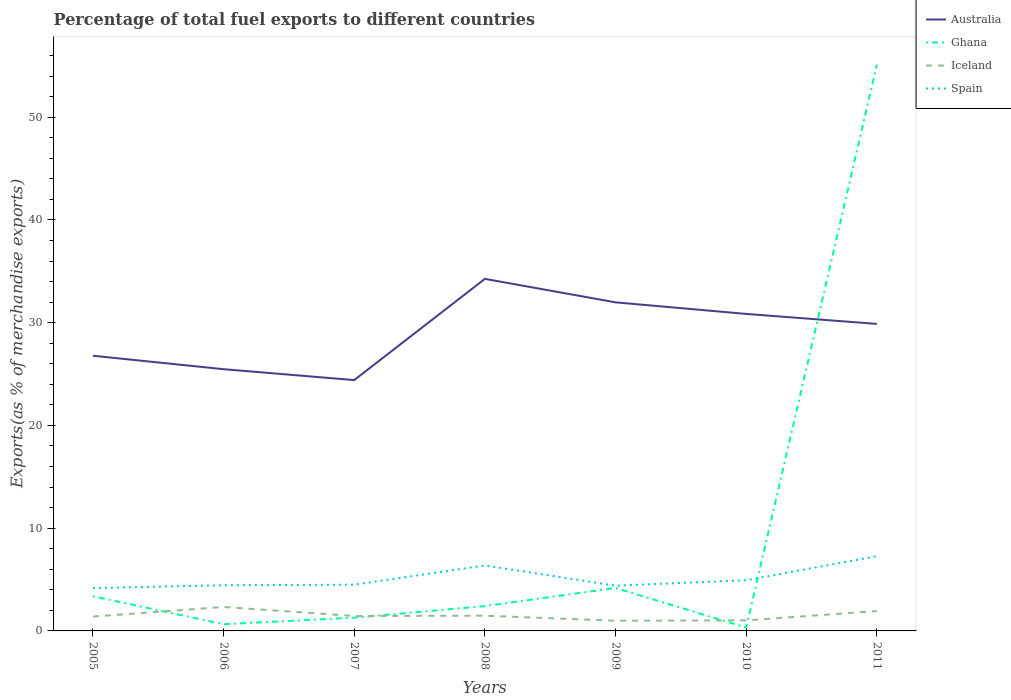Is the number of lines equal to the number of legend labels?
Ensure brevity in your answer.  Yes. Across all years, what is the maximum percentage of exports to different countries in Australia?
Ensure brevity in your answer.  24.42. What is the total percentage of exports to different countries in Spain in the graph?
Ensure brevity in your answer.  -0.27. What is the difference between the highest and the second highest percentage of exports to different countries in Ghana?
Your answer should be compact. 54.79. Is the percentage of exports to different countries in Ghana strictly greater than the percentage of exports to different countries in Spain over the years?
Offer a terse response. No. How many lines are there?
Provide a succinct answer. 4. Does the graph contain grids?
Make the answer very short. No. Where does the legend appear in the graph?
Offer a very short reply. Top right. How many legend labels are there?
Provide a succinct answer. 4. How are the legend labels stacked?
Ensure brevity in your answer.  Vertical. What is the title of the graph?
Keep it short and to the point. Percentage of total fuel exports to different countries. Does "Belgium" appear as one of the legend labels in the graph?
Give a very brief answer. No. What is the label or title of the X-axis?
Keep it short and to the point. Years. What is the label or title of the Y-axis?
Ensure brevity in your answer.  Exports(as % of merchandise exports). What is the Exports(as % of merchandise exports) of Australia in 2005?
Make the answer very short. 26.79. What is the Exports(as % of merchandise exports) of Ghana in 2005?
Provide a succinct answer. 3.38. What is the Exports(as % of merchandise exports) of Iceland in 2005?
Your answer should be very brief. 1.4. What is the Exports(as % of merchandise exports) of Spain in 2005?
Provide a succinct answer. 4.17. What is the Exports(as % of merchandise exports) in Australia in 2006?
Your answer should be compact. 25.48. What is the Exports(as % of merchandise exports) in Ghana in 2006?
Offer a terse response. 0.65. What is the Exports(as % of merchandise exports) of Iceland in 2006?
Make the answer very short. 2.33. What is the Exports(as % of merchandise exports) in Spain in 2006?
Your answer should be compact. 4.45. What is the Exports(as % of merchandise exports) in Australia in 2007?
Provide a short and direct response. 24.42. What is the Exports(as % of merchandise exports) of Ghana in 2007?
Ensure brevity in your answer.  1.29. What is the Exports(as % of merchandise exports) of Iceland in 2007?
Make the answer very short. 1.45. What is the Exports(as % of merchandise exports) in Spain in 2007?
Ensure brevity in your answer.  4.5. What is the Exports(as % of merchandise exports) of Australia in 2008?
Provide a succinct answer. 34.27. What is the Exports(as % of merchandise exports) of Ghana in 2008?
Keep it short and to the point. 2.42. What is the Exports(as % of merchandise exports) in Iceland in 2008?
Provide a succinct answer. 1.48. What is the Exports(as % of merchandise exports) in Spain in 2008?
Provide a succinct answer. 6.37. What is the Exports(as % of merchandise exports) of Australia in 2009?
Offer a terse response. 31.98. What is the Exports(as % of merchandise exports) in Ghana in 2009?
Your answer should be very brief. 4.18. What is the Exports(as % of merchandise exports) of Iceland in 2009?
Provide a short and direct response. 0.99. What is the Exports(as % of merchandise exports) of Spain in 2009?
Your answer should be compact. 4.41. What is the Exports(as % of merchandise exports) of Australia in 2010?
Provide a succinct answer. 30.86. What is the Exports(as % of merchandise exports) in Ghana in 2010?
Provide a short and direct response. 0.32. What is the Exports(as % of merchandise exports) of Iceland in 2010?
Give a very brief answer. 1.03. What is the Exports(as % of merchandise exports) of Spain in 2010?
Provide a succinct answer. 4.93. What is the Exports(as % of merchandise exports) of Australia in 2011?
Your answer should be compact. 29.88. What is the Exports(as % of merchandise exports) in Ghana in 2011?
Offer a very short reply. 55.11. What is the Exports(as % of merchandise exports) in Iceland in 2011?
Your answer should be very brief. 1.93. What is the Exports(as % of merchandise exports) in Spain in 2011?
Your response must be concise. 7.27. Across all years, what is the maximum Exports(as % of merchandise exports) in Australia?
Provide a short and direct response. 34.27. Across all years, what is the maximum Exports(as % of merchandise exports) of Ghana?
Provide a succinct answer. 55.11. Across all years, what is the maximum Exports(as % of merchandise exports) of Iceland?
Offer a terse response. 2.33. Across all years, what is the maximum Exports(as % of merchandise exports) in Spain?
Offer a terse response. 7.27. Across all years, what is the minimum Exports(as % of merchandise exports) of Australia?
Keep it short and to the point. 24.42. Across all years, what is the minimum Exports(as % of merchandise exports) in Ghana?
Give a very brief answer. 0.32. Across all years, what is the minimum Exports(as % of merchandise exports) of Iceland?
Provide a succinct answer. 0.99. Across all years, what is the minimum Exports(as % of merchandise exports) of Spain?
Keep it short and to the point. 4.17. What is the total Exports(as % of merchandise exports) in Australia in the graph?
Provide a succinct answer. 203.67. What is the total Exports(as % of merchandise exports) in Ghana in the graph?
Your response must be concise. 67.36. What is the total Exports(as % of merchandise exports) in Iceland in the graph?
Your answer should be compact. 10.62. What is the total Exports(as % of merchandise exports) in Spain in the graph?
Make the answer very short. 36.11. What is the difference between the Exports(as % of merchandise exports) of Australia in 2005 and that in 2006?
Provide a short and direct response. 1.31. What is the difference between the Exports(as % of merchandise exports) in Ghana in 2005 and that in 2006?
Your answer should be compact. 2.72. What is the difference between the Exports(as % of merchandise exports) of Iceland in 2005 and that in 2006?
Provide a short and direct response. -0.93. What is the difference between the Exports(as % of merchandise exports) in Spain in 2005 and that in 2006?
Ensure brevity in your answer.  -0.27. What is the difference between the Exports(as % of merchandise exports) of Australia in 2005 and that in 2007?
Your response must be concise. 2.37. What is the difference between the Exports(as % of merchandise exports) in Ghana in 2005 and that in 2007?
Your response must be concise. 2.08. What is the difference between the Exports(as % of merchandise exports) in Iceland in 2005 and that in 2007?
Offer a terse response. -0.06. What is the difference between the Exports(as % of merchandise exports) in Spain in 2005 and that in 2007?
Offer a terse response. -0.33. What is the difference between the Exports(as % of merchandise exports) in Australia in 2005 and that in 2008?
Your answer should be compact. -7.48. What is the difference between the Exports(as % of merchandise exports) in Ghana in 2005 and that in 2008?
Provide a short and direct response. 0.96. What is the difference between the Exports(as % of merchandise exports) in Iceland in 2005 and that in 2008?
Offer a very short reply. -0.09. What is the difference between the Exports(as % of merchandise exports) in Spain in 2005 and that in 2008?
Your answer should be very brief. -2.2. What is the difference between the Exports(as % of merchandise exports) of Australia in 2005 and that in 2009?
Provide a succinct answer. -5.2. What is the difference between the Exports(as % of merchandise exports) of Ghana in 2005 and that in 2009?
Give a very brief answer. -0.81. What is the difference between the Exports(as % of merchandise exports) of Iceland in 2005 and that in 2009?
Offer a very short reply. 0.41. What is the difference between the Exports(as % of merchandise exports) in Spain in 2005 and that in 2009?
Keep it short and to the point. -0.23. What is the difference between the Exports(as % of merchandise exports) in Australia in 2005 and that in 2010?
Offer a very short reply. -4.07. What is the difference between the Exports(as % of merchandise exports) in Ghana in 2005 and that in 2010?
Keep it short and to the point. 3.05. What is the difference between the Exports(as % of merchandise exports) in Iceland in 2005 and that in 2010?
Provide a short and direct response. 0.37. What is the difference between the Exports(as % of merchandise exports) of Spain in 2005 and that in 2010?
Provide a short and direct response. -0.76. What is the difference between the Exports(as % of merchandise exports) in Australia in 2005 and that in 2011?
Your answer should be compact. -3.1. What is the difference between the Exports(as % of merchandise exports) of Ghana in 2005 and that in 2011?
Your response must be concise. -51.74. What is the difference between the Exports(as % of merchandise exports) in Iceland in 2005 and that in 2011?
Your response must be concise. -0.54. What is the difference between the Exports(as % of merchandise exports) of Spain in 2005 and that in 2011?
Give a very brief answer. -3.1. What is the difference between the Exports(as % of merchandise exports) in Australia in 2006 and that in 2007?
Your answer should be compact. 1.06. What is the difference between the Exports(as % of merchandise exports) in Ghana in 2006 and that in 2007?
Your answer should be very brief. -0.64. What is the difference between the Exports(as % of merchandise exports) of Iceland in 2006 and that in 2007?
Your answer should be very brief. 0.88. What is the difference between the Exports(as % of merchandise exports) in Spain in 2006 and that in 2007?
Provide a succinct answer. -0.05. What is the difference between the Exports(as % of merchandise exports) of Australia in 2006 and that in 2008?
Your answer should be very brief. -8.79. What is the difference between the Exports(as % of merchandise exports) of Ghana in 2006 and that in 2008?
Your response must be concise. -1.76. What is the difference between the Exports(as % of merchandise exports) of Iceland in 2006 and that in 2008?
Ensure brevity in your answer.  0.85. What is the difference between the Exports(as % of merchandise exports) in Spain in 2006 and that in 2008?
Offer a terse response. -1.93. What is the difference between the Exports(as % of merchandise exports) in Australia in 2006 and that in 2009?
Offer a terse response. -6.51. What is the difference between the Exports(as % of merchandise exports) in Ghana in 2006 and that in 2009?
Offer a terse response. -3.53. What is the difference between the Exports(as % of merchandise exports) in Iceland in 2006 and that in 2009?
Offer a very short reply. 1.34. What is the difference between the Exports(as % of merchandise exports) in Spain in 2006 and that in 2009?
Ensure brevity in your answer.  0.04. What is the difference between the Exports(as % of merchandise exports) of Australia in 2006 and that in 2010?
Offer a very short reply. -5.38. What is the difference between the Exports(as % of merchandise exports) in Ghana in 2006 and that in 2010?
Provide a succinct answer. 0.33. What is the difference between the Exports(as % of merchandise exports) of Iceland in 2006 and that in 2010?
Give a very brief answer. 1.3. What is the difference between the Exports(as % of merchandise exports) of Spain in 2006 and that in 2010?
Your answer should be compact. -0.49. What is the difference between the Exports(as % of merchandise exports) in Australia in 2006 and that in 2011?
Provide a succinct answer. -4.41. What is the difference between the Exports(as % of merchandise exports) in Ghana in 2006 and that in 2011?
Provide a succinct answer. -54.46. What is the difference between the Exports(as % of merchandise exports) of Iceland in 2006 and that in 2011?
Offer a very short reply. 0.4. What is the difference between the Exports(as % of merchandise exports) of Spain in 2006 and that in 2011?
Make the answer very short. -2.82. What is the difference between the Exports(as % of merchandise exports) of Australia in 2007 and that in 2008?
Provide a short and direct response. -9.85. What is the difference between the Exports(as % of merchandise exports) of Ghana in 2007 and that in 2008?
Keep it short and to the point. -1.12. What is the difference between the Exports(as % of merchandise exports) of Iceland in 2007 and that in 2008?
Provide a short and direct response. -0.03. What is the difference between the Exports(as % of merchandise exports) of Spain in 2007 and that in 2008?
Give a very brief answer. -1.87. What is the difference between the Exports(as % of merchandise exports) of Australia in 2007 and that in 2009?
Your response must be concise. -7.57. What is the difference between the Exports(as % of merchandise exports) in Ghana in 2007 and that in 2009?
Give a very brief answer. -2.89. What is the difference between the Exports(as % of merchandise exports) of Iceland in 2007 and that in 2009?
Provide a short and direct response. 0.46. What is the difference between the Exports(as % of merchandise exports) of Spain in 2007 and that in 2009?
Your answer should be very brief. 0.1. What is the difference between the Exports(as % of merchandise exports) in Australia in 2007 and that in 2010?
Your response must be concise. -6.44. What is the difference between the Exports(as % of merchandise exports) in Ghana in 2007 and that in 2010?
Offer a very short reply. 0.97. What is the difference between the Exports(as % of merchandise exports) in Iceland in 2007 and that in 2010?
Provide a succinct answer. 0.43. What is the difference between the Exports(as % of merchandise exports) of Spain in 2007 and that in 2010?
Offer a very short reply. -0.43. What is the difference between the Exports(as % of merchandise exports) of Australia in 2007 and that in 2011?
Provide a short and direct response. -5.47. What is the difference between the Exports(as % of merchandise exports) of Ghana in 2007 and that in 2011?
Offer a terse response. -53.82. What is the difference between the Exports(as % of merchandise exports) in Iceland in 2007 and that in 2011?
Provide a short and direct response. -0.48. What is the difference between the Exports(as % of merchandise exports) in Spain in 2007 and that in 2011?
Provide a short and direct response. -2.77. What is the difference between the Exports(as % of merchandise exports) of Australia in 2008 and that in 2009?
Offer a very short reply. 2.29. What is the difference between the Exports(as % of merchandise exports) of Ghana in 2008 and that in 2009?
Your response must be concise. -1.77. What is the difference between the Exports(as % of merchandise exports) in Iceland in 2008 and that in 2009?
Your answer should be very brief. 0.49. What is the difference between the Exports(as % of merchandise exports) of Spain in 2008 and that in 2009?
Provide a succinct answer. 1.97. What is the difference between the Exports(as % of merchandise exports) of Australia in 2008 and that in 2010?
Keep it short and to the point. 3.41. What is the difference between the Exports(as % of merchandise exports) of Ghana in 2008 and that in 2010?
Your answer should be very brief. 2.09. What is the difference between the Exports(as % of merchandise exports) of Iceland in 2008 and that in 2010?
Your answer should be compact. 0.45. What is the difference between the Exports(as % of merchandise exports) of Spain in 2008 and that in 2010?
Make the answer very short. 1.44. What is the difference between the Exports(as % of merchandise exports) in Australia in 2008 and that in 2011?
Make the answer very short. 4.38. What is the difference between the Exports(as % of merchandise exports) in Ghana in 2008 and that in 2011?
Your answer should be very brief. -52.7. What is the difference between the Exports(as % of merchandise exports) in Iceland in 2008 and that in 2011?
Ensure brevity in your answer.  -0.45. What is the difference between the Exports(as % of merchandise exports) of Spain in 2008 and that in 2011?
Offer a terse response. -0.9. What is the difference between the Exports(as % of merchandise exports) of Australia in 2009 and that in 2010?
Offer a very short reply. 1.13. What is the difference between the Exports(as % of merchandise exports) of Ghana in 2009 and that in 2010?
Your answer should be very brief. 3.86. What is the difference between the Exports(as % of merchandise exports) in Iceland in 2009 and that in 2010?
Provide a succinct answer. -0.04. What is the difference between the Exports(as % of merchandise exports) of Spain in 2009 and that in 2010?
Offer a terse response. -0.53. What is the difference between the Exports(as % of merchandise exports) of Australia in 2009 and that in 2011?
Offer a terse response. 2.1. What is the difference between the Exports(as % of merchandise exports) of Ghana in 2009 and that in 2011?
Your answer should be compact. -50.93. What is the difference between the Exports(as % of merchandise exports) in Iceland in 2009 and that in 2011?
Provide a short and direct response. -0.94. What is the difference between the Exports(as % of merchandise exports) in Spain in 2009 and that in 2011?
Keep it short and to the point. -2.87. What is the difference between the Exports(as % of merchandise exports) in Australia in 2010 and that in 2011?
Give a very brief answer. 0.97. What is the difference between the Exports(as % of merchandise exports) in Ghana in 2010 and that in 2011?
Ensure brevity in your answer.  -54.79. What is the difference between the Exports(as % of merchandise exports) in Iceland in 2010 and that in 2011?
Your response must be concise. -0.9. What is the difference between the Exports(as % of merchandise exports) of Spain in 2010 and that in 2011?
Offer a terse response. -2.34. What is the difference between the Exports(as % of merchandise exports) of Australia in 2005 and the Exports(as % of merchandise exports) of Ghana in 2006?
Provide a succinct answer. 26.13. What is the difference between the Exports(as % of merchandise exports) in Australia in 2005 and the Exports(as % of merchandise exports) in Iceland in 2006?
Offer a terse response. 24.45. What is the difference between the Exports(as % of merchandise exports) in Australia in 2005 and the Exports(as % of merchandise exports) in Spain in 2006?
Offer a terse response. 22.34. What is the difference between the Exports(as % of merchandise exports) of Ghana in 2005 and the Exports(as % of merchandise exports) of Iceland in 2006?
Your answer should be very brief. 1.04. What is the difference between the Exports(as % of merchandise exports) of Ghana in 2005 and the Exports(as % of merchandise exports) of Spain in 2006?
Provide a succinct answer. -1.07. What is the difference between the Exports(as % of merchandise exports) of Iceland in 2005 and the Exports(as % of merchandise exports) of Spain in 2006?
Keep it short and to the point. -3.05. What is the difference between the Exports(as % of merchandise exports) in Australia in 2005 and the Exports(as % of merchandise exports) in Ghana in 2007?
Offer a terse response. 25.49. What is the difference between the Exports(as % of merchandise exports) of Australia in 2005 and the Exports(as % of merchandise exports) of Iceland in 2007?
Your answer should be very brief. 25.33. What is the difference between the Exports(as % of merchandise exports) of Australia in 2005 and the Exports(as % of merchandise exports) of Spain in 2007?
Your response must be concise. 22.28. What is the difference between the Exports(as % of merchandise exports) of Ghana in 2005 and the Exports(as % of merchandise exports) of Iceland in 2007?
Your answer should be very brief. 1.92. What is the difference between the Exports(as % of merchandise exports) in Ghana in 2005 and the Exports(as % of merchandise exports) in Spain in 2007?
Offer a very short reply. -1.13. What is the difference between the Exports(as % of merchandise exports) in Iceland in 2005 and the Exports(as % of merchandise exports) in Spain in 2007?
Keep it short and to the point. -3.1. What is the difference between the Exports(as % of merchandise exports) of Australia in 2005 and the Exports(as % of merchandise exports) of Ghana in 2008?
Make the answer very short. 24.37. What is the difference between the Exports(as % of merchandise exports) in Australia in 2005 and the Exports(as % of merchandise exports) in Iceland in 2008?
Offer a very short reply. 25.3. What is the difference between the Exports(as % of merchandise exports) of Australia in 2005 and the Exports(as % of merchandise exports) of Spain in 2008?
Keep it short and to the point. 20.41. What is the difference between the Exports(as % of merchandise exports) of Ghana in 2005 and the Exports(as % of merchandise exports) of Iceland in 2008?
Keep it short and to the point. 1.89. What is the difference between the Exports(as % of merchandise exports) in Ghana in 2005 and the Exports(as % of merchandise exports) in Spain in 2008?
Ensure brevity in your answer.  -3. What is the difference between the Exports(as % of merchandise exports) of Iceland in 2005 and the Exports(as % of merchandise exports) of Spain in 2008?
Offer a terse response. -4.98. What is the difference between the Exports(as % of merchandise exports) in Australia in 2005 and the Exports(as % of merchandise exports) in Ghana in 2009?
Your answer should be compact. 22.6. What is the difference between the Exports(as % of merchandise exports) of Australia in 2005 and the Exports(as % of merchandise exports) of Iceland in 2009?
Keep it short and to the point. 25.79. What is the difference between the Exports(as % of merchandise exports) in Australia in 2005 and the Exports(as % of merchandise exports) in Spain in 2009?
Provide a succinct answer. 22.38. What is the difference between the Exports(as % of merchandise exports) in Ghana in 2005 and the Exports(as % of merchandise exports) in Iceland in 2009?
Ensure brevity in your answer.  2.38. What is the difference between the Exports(as % of merchandise exports) of Ghana in 2005 and the Exports(as % of merchandise exports) of Spain in 2009?
Provide a succinct answer. -1.03. What is the difference between the Exports(as % of merchandise exports) of Iceland in 2005 and the Exports(as % of merchandise exports) of Spain in 2009?
Ensure brevity in your answer.  -3.01. What is the difference between the Exports(as % of merchandise exports) in Australia in 2005 and the Exports(as % of merchandise exports) in Ghana in 2010?
Keep it short and to the point. 26.46. What is the difference between the Exports(as % of merchandise exports) of Australia in 2005 and the Exports(as % of merchandise exports) of Iceland in 2010?
Ensure brevity in your answer.  25.76. What is the difference between the Exports(as % of merchandise exports) of Australia in 2005 and the Exports(as % of merchandise exports) of Spain in 2010?
Your answer should be very brief. 21.85. What is the difference between the Exports(as % of merchandise exports) of Ghana in 2005 and the Exports(as % of merchandise exports) of Iceland in 2010?
Keep it short and to the point. 2.35. What is the difference between the Exports(as % of merchandise exports) in Ghana in 2005 and the Exports(as % of merchandise exports) in Spain in 2010?
Provide a short and direct response. -1.56. What is the difference between the Exports(as % of merchandise exports) of Iceland in 2005 and the Exports(as % of merchandise exports) of Spain in 2010?
Your answer should be compact. -3.54. What is the difference between the Exports(as % of merchandise exports) of Australia in 2005 and the Exports(as % of merchandise exports) of Ghana in 2011?
Ensure brevity in your answer.  -28.33. What is the difference between the Exports(as % of merchandise exports) of Australia in 2005 and the Exports(as % of merchandise exports) of Iceland in 2011?
Your response must be concise. 24.85. What is the difference between the Exports(as % of merchandise exports) of Australia in 2005 and the Exports(as % of merchandise exports) of Spain in 2011?
Provide a succinct answer. 19.51. What is the difference between the Exports(as % of merchandise exports) of Ghana in 2005 and the Exports(as % of merchandise exports) of Iceland in 2011?
Keep it short and to the point. 1.44. What is the difference between the Exports(as % of merchandise exports) of Ghana in 2005 and the Exports(as % of merchandise exports) of Spain in 2011?
Your response must be concise. -3.9. What is the difference between the Exports(as % of merchandise exports) of Iceland in 2005 and the Exports(as % of merchandise exports) of Spain in 2011?
Give a very brief answer. -5.87. What is the difference between the Exports(as % of merchandise exports) of Australia in 2006 and the Exports(as % of merchandise exports) of Ghana in 2007?
Offer a terse response. 24.18. What is the difference between the Exports(as % of merchandise exports) in Australia in 2006 and the Exports(as % of merchandise exports) in Iceland in 2007?
Offer a very short reply. 24.02. What is the difference between the Exports(as % of merchandise exports) in Australia in 2006 and the Exports(as % of merchandise exports) in Spain in 2007?
Offer a terse response. 20.98. What is the difference between the Exports(as % of merchandise exports) in Ghana in 2006 and the Exports(as % of merchandise exports) in Iceland in 2007?
Keep it short and to the point. -0.8. What is the difference between the Exports(as % of merchandise exports) in Ghana in 2006 and the Exports(as % of merchandise exports) in Spain in 2007?
Keep it short and to the point. -3.85. What is the difference between the Exports(as % of merchandise exports) in Iceland in 2006 and the Exports(as % of merchandise exports) in Spain in 2007?
Keep it short and to the point. -2.17. What is the difference between the Exports(as % of merchandise exports) of Australia in 2006 and the Exports(as % of merchandise exports) of Ghana in 2008?
Keep it short and to the point. 23.06. What is the difference between the Exports(as % of merchandise exports) of Australia in 2006 and the Exports(as % of merchandise exports) of Iceland in 2008?
Provide a succinct answer. 23.99. What is the difference between the Exports(as % of merchandise exports) in Australia in 2006 and the Exports(as % of merchandise exports) in Spain in 2008?
Your answer should be compact. 19.1. What is the difference between the Exports(as % of merchandise exports) of Ghana in 2006 and the Exports(as % of merchandise exports) of Iceland in 2008?
Your response must be concise. -0.83. What is the difference between the Exports(as % of merchandise exports) in Ghana in 2006 and the Exports(as % of merchandise exports) in Spain in 2008?
Offer a terse response. -5.72. What is the difference between the Exports(as % of merchandise exports) in Iceland in 2006 and the Exports(as % of merchandise exports) in Spain in 2008?
Your answer should be very brief. -4.04. What is the difference between the Exports(as % of merchandise exports) of Australia in 2006 and the Exports(as % of merchandise exports) of Ghana in 2009?
Your response must be concise. 21.29. What is the difference between the Exports(as % of merchandise exports) of Australia in 2006 and the Exports(as % of merchandise exports) of Iceland in 2009?
Provide a short and direct response. 24.48. What is the difference between the Exports(as % of merchandise exports) in Australia in 2006 and the Exports(as % of merchandise exports) in Spain in 2009?
Offer a terse response. 21.07. What is the difference between the Exports(as % of merchandise exports) in Ghana in 2006 and the Exports(as % of merchandise exports) in Iceland in 2009?
Give a very brief answer. -0.34. What is the difference between the Exports(as % of merchandise exports) of Ghana in 2006 and the Exports(as % of merchandise exports) of Spain in 2009?
Ensure brevity in your answer.  -3.75. What is the difference between the Exports(as % of merchandise exports) of Iceland in 2006 and the Exports(as % of merchandise exports) of Spain in 2009?
Offer a terse response. -2.07. What is the difference between the Exports(as % of merchandise exports) in Australia in 2006 and the Exports(as % of merchandise exports) in Ghana in 2010?
Provide a short and direct response. 25.15. What is the difference between the Exports(as % of merchandise exports) in Australia in 2006 and the Exports(as % of merchandise exports) in Iceland in 2010?
Offer a terse response. 24.45. What is the difference between the Exports(as % of merchandise exports) in Australia in 2006 and the Exports(as % of merchandise exports) in Spain in 2010?
Keep it short and to the point. 20.54. What is the difference between the Exports(as % of merchandise exports) of Ghana in 2006 and the Exports(as % of merchandise exports) of Iceland in 2010?
Your answer should be very brief. -0.37. What is the difference between the Exports(as % of merchandise exports) in Ghana in 2006 and the Exports(as % of merchandise exports) in Spain in 2010?
Offer a very short reply. -4.28. What is the difference between the Exports(as % of merchandise exports) of Iceland in 2006 and the Exports(as % of merchandise exports) of Spain in 2010?
Your answer should be compact. -2.6. What is the difference between the Exports(as % of merchandise exports) in Australia in 2006 and the Exports(as % of merchandise exports) in Ghana in 2011?
Provide a succinct answer. -29.64. What is the difference between the Exports(as % of merchandise exports) in Australia in 2006 and the Exports(as % of merchandise exports) in Iceland in 2011?
Offer a very short reply. 23.54. What is the difference between the Exports(as % of merchandise exports) in Australia in 2006 and the Exports(as % of merchandise exports) in Spain in 2011?
Your answer should be very brief. 18.2. What is the difference between the Exports(as % of merchandise exports) in Ghana in 2006 and the Exports(as % of merchandise exports) in Iceland in 2011?
Give a very brief answer. -1.28. What is the difference between the Exports(as % of merchandise exports) of Ghana in 2006 and the Exports(as % of merchandise exports) of Spain in 2011?
Give a very brief answer. -6.62. What is the difference between the Exports(as % of merchandise exports) in Iceland in 2006 and the Exports(as % of merchandise exports) in Spain in 2011?
Your answer should be compact. -4.94. What is the difference between the Exports(as % of merchandise exports) in Australia in 2007 and the Exports(as % of merchandise exports) in Ghana in 2008?
Provide a short and direct response. 22. What is the difference between the Exports(as % of merchandise exports) of Australia in 2007 and the Exports(as % of merchandise exports) of Iceland in 2008?
Offer a very short reply. 22.93. What is the difference between the Exports(as % of merchandise exports) of Australia in 2007 and the Exports(as % of merchandise exports) of Spain in 2008?
Offer a very short reply. 18.04. What is the difference between the Exports(as % of merchandise exports) of Ghana in 2007 and the Exports(as % of merchandise exports) of Iceland in 2008?
Provide a short and direct response. -0.19. What is the difference between the Exports(as % of merchandise exports) in Ghana in 2007 and the Exports(as % of merchandise exports) in Spain in 2008?
Make the answer very short. -5.08. What is the difference between the Exports(as % of merchandise exports) of Iceland in 2007 and the Exports(as % of merchandise exports) of Spain in 2008?
Provide a succinct answer. -4.92. What is the difference between the Exports(as % of merchandise exports) of Australia in 2007 and the Exports(as % of merchandise exports) of Ghana in 2009?
Your answer should be very brief. 20.23. What is the difference between the Exports(as % of merchandise exports) of Australia in 2007 and the Exports(as % of merchandise exports) of Iceland in 2009?
Your answer should be very brief. 23.42. What is the difference between the Exports(as % of merchandise exports) of Australia in 2007 and the Exports(as % of merchandise exports) of Spain in 2009?
Make the answer very short. 20.01. What is the difference between the Exports(as % of merchandise exports) of Ghana in 2007 and the Exports(as % of merchandise exports) of Iceland in 2009?
Make the answer very short. 0.3. What is the difference between the Exports(as % of merchandise exports) in Ghana in 2007 and the Exports(as % of merchandise exports) in Spain in 2009?
Ensure brevity in your answer.  -3.11. What is the difference between the Exports(as % of merchandise exports) of Iceland in 2007 and the Exports(as % of merchandise exports) of Spain in 2009?
Keep it short and to the point. -2.95. What is the difference between the Exports(as % of merchandise exports) of Australia in 2007 and the Exports(as % of merchandise exports) of Ghana in 2010?
Provide a short and direct response. 24.09. What is the difference between the Exports(as % of merchandise exports) in Australia in 2007 and the Exports(as % of merchandise exports) in Iceland in 2010?
Ensure brevity in your answer.  23.39. What is the difference between the Exports(as % of merchandise exports) of Australia in 2007 and the Exports(as % of merchandise exports) of Spain in 2010?
Provide a short and direct response. 19.48. What is the difference between the Exports(as % of merchandise exports) in Ghana in 2007 and the Exports(as % of merchandise exports) in Iceland in 2010?
Make the answer very short. 0.26. What is the difference between the Exports(as % of merchandise exports) in Ghana in 2007 and the Exports(as % of merchandise exports) in Spain in 2010?
Make the answer very short. -3.64. What is the difference between the Exports(as % of merchandise exports) of Iceland in 2007 and the Exports(as % of merchandise exports) of Spain in 2010?
Offer a terse response. -3.48. What is the difference between the Exports(as % of merchandise exports) in Australia in 2007 and the Exports(as % of merchandise exports) in Ghana in 2011?
Offer a very short reply. -30.7. What is the difference between the Exports(as % of merchandise exports) of Australia in 2007 and the Exports(as % of merchandise exports) of Iceland in 2011?
Provide a short and direct response. 22.48. What is the difference between the Exports(as % of merchandise exports) of Australia in 2007 and the Exports(as % of merchandise exports) of Spain in 2011?
Offer a very short reply. 17.14. What is the difference between the Exports(as % of merchandise exports) in Ghana in 2007 and the Exports(as % of merchandise exports) in Iceland in 2011?
Your answer should be very brief. -0.64. What is the difference between the Exports(as % of merchandise exports) of Ghana in 2007 and the Exports(as % of merchandise exports) of Spain in 2011?
Keep it short and to the point. -5.98. What is the difference between the Exports(as % of merchandise exports) of Iceland in 2007 and the Exports(as % of merchandise exports) of Spain in 2011?
Ensure brevity in your answer.  -5.82. What is the difference between the Exports(as % of merchandise exports) in Australia in 2008 and the Exports(as % of merchandise exports) in Ghana in 2009?
Keep it short and to the point. 30.08. What is the difference between the Exports(as % of merchandise exports) in Australia in 2008 and the Exports(as % of merchandise exports) in Iceland in 2009?
Offer a terse response. 33.27. What is the difference between the Exports(as % of merchandise exports) in Australia in 2008 and the Exports(as % of merchandise exports) in Spain in 2009?
Make the answer very short. 29.86. What is the difference between the Exports(as % of merchandise exports) in Ghana in 2008 and the Exports(as % of merchandise exports) in Iceland in 2009?
Your response must be concise. 1.42. What is the difference between the Exports(as % of merchandise exports) in Ghana in 2008 and the Exports(as % of merchandise exports) in Spain in 2009?
Provide a succinct answer. -1.99. What is the difference between the Exports(as % of merchandise exports) in Iceland in 2008 and the Exports(as % of merchandise exports) in Spain in 2009?
Provide a succinct answer. -2.92. What is the difference between the Exports(as % of merchandise exports) in Australia in 2008 and the Exports(as % of merchandise exports) in Ghana in 2010?
Offer a terse response. 33.94. What is the difference between the Exports(as % of merchandise exports) in Australia in 2008 and the Exports(as % of merchandise exports) in Iceland in 2010?
Give a very brief answer. 33.24. What is the difference between the Exports(as % of merchandise exports) of Australia in 2008 and the Exports(as % of merchandise exports) of Spain in 2010?
Your response must be concise. 29.33. What is the difference between the Exports(as % of merchandise exports) in Ghana in 2008 and the Exports(as % of merchandise exports) in Iceland in 2010?
Ensure brevity in your answer.  1.39. What is the difference between the Exports(as % of merchandise exports) of Ghana in 2008 and the Exports(as % of merchandise exports) of Spain in 2010?
Offer a terse response. -2.52. What is the difference between the Exports(as % of merchandise exports) in Iceland in 2008 and the Exports(as % of merchandise exports) in Spain in 2010?
Offer a terse response. -3.45. What is the difference between the Exports(as % of merchandise exports) in Australia in 2008 and the Exports(as % of merchandise exports) in Ghana in 2011?
Provide a short and direct response. -20.85. What is the difference between the Exports(as % of merchandise exports) in Australia in 2008 and the Exports(as % of merchandise exports) in Iceland in 2011?
Your answer should be compact. 32.33. What is the difference between the Exports(as % of merchandise exports) in Australia in 2008 and the Exports(as % of merchandise exports) in Spain in 2011?
Offer a very short reply. 27. What is the difference between the Exports(as % of merchandise exports) of Ghana in 2008 and the Exports(as % of merchandise exports) of Iceland in 2011?
Your answer should be compact. 0.48. What is the difference between the Exports(as % of merchandise exports) of Ghana in 2008 and the Exports(as % of merchandise exports) of Spain in 2011?
Provide a succinct answer. -4.86. What is the difference between the Exports(as % of merchandise exports) of Iceland in 2008 and the Exports(as % of merchandise exports) of Spain in 2011?
Your response must be concise. -5.79. What is the difference between the Exports(as % of merchandise exports) in Australia in 2009 and the Exports(as % of merchandise exports) in Ghana in 2010?
Your answer should be compact. 31.66. What is the difference between the Exports(as % of merchandise exports) in Australia in 2009 and the Exports(as % of merchandise exports) in Iceland in 2010?
Make the answer very short. 30.95. What is the difference between the Exports(as % of merchandise exports) of Australia in 2009 and the Exports(as % of merchandise exports) of Spain in 2010?
Provide a succinct answer. 27.05. What is the difference between the Exports(as % of merchandise exports) in Ghana in 2009 and the Exports(as % of merchandise exports) in Iceland in 2010?
Make the answer very short. 3.15. What is the difference between the Exports(as % of merchandise exports) of Ghana in 2009 and the Exports(as % of merchandise exports) of Spain in 2010?
Keep it short and to the point. -0.75. What is the difference between the Exports(as % of merchandise exports) of Iceland in 2009 and the Exports(as % of merchandise exports) of Spain in 2010?
Ensure brevity in your answer.  -3.94. What is the difference between the Exports(as % of merchandise exports) of Australia in 2009 and the Exports(as % of merchandise exports) of Ghana in 2011?
Keep it short and to the point. -23.13. What is the difference between the Exports(as % of merchandise exports) in Australia in 2009 and the Exports(as % of merchandise exports) in Iceland in 2011?
Your response must be concise. 30.05. What is the difference between the Exports(as % of merchandise exports) of Australia in 2009 and the Exports(as % of merchandise exports) of Spain in 2011?
Your answer should be very brief. 24.71. What is the difference between the Exports(as % of merchandise exports) in Ghana in 2009 and the Exports(as % of merchandise exports) in Iceland in 2011?
Your answer should be compact. 2.25. What is the difference between the Exports(as % of merchandise exports) of Ghana in 2009 and the Exports(as % of merchandise exports) of Spain in 2011?
Your response must be concise. -3.09. What is the difference between the Exports(as % of merchandise exports) of Iceland in 2009 and the Exports(as % of merchandise exports) of Spain in 2011?
Keep it short and to the point. -6.28. What is the difference between the Exports(as % of merchandise exports) in Australia in 2010 and the Exports(as % of merchandise exports) in Ghana in 2011?
Offer a terse response. -24.26. What is the difference between the Exports(as % of merchandise exports) in Australia in 2010 and the Exports(as % of merchandise exports) in Iceland in 2011?
Make the answer very short. 28.92. What is the difference between the Exports(as % of merchandise exports) in Australia in 2010 and the Exports(as % of merchandise exports) in Spain in 2011?
Offer a very short reply. 23.58. What is the difference between the Exports(as % of merchandise exports) in Ghana in 2010 and the Exports(as % of merchandise exports) in Iceland in 2011?
Provide a succinct answer. -1.61. What is the difference between the Exports(as % of merchandise exports) of Ghana in 2010 and the Exports(as % of merchandise exports) of Spain in 2011?
Your answer should be compact. -6.95. What is the difference between the Exports(as % of merchandise exports) in Iceland in 2010 and the Exports(as % of merchandise exports) in Spain in 2011?
Ensure brevity in your answer.  -6.24. What is the average Exports(as % of merchandise exports) in Australia per year?
Provide a short and direct response. 29.1. What is the average Exports(as % of merchandise exports) in Ghana per year?
Make the answer very short. 9.62. What is the average Exports(as % of merchandise exports) of Iceland per year?
Your response must be concise. 1.52. What is the average Exports(as % of merchandise exports) in Spain per year?
Your response must be concise. 5.16. In the year 2005, what is the difference between the Exports(as % of merchandise exports) of Australia and Exports(as % of merchandise exports) of Ghana?
Your response must be concise. 23.41. In the year 2005, what is the difference between the Exports(as % of merchandise exports) in Australia and Exports(as % of merchandise exports) in Iceland?
Your answer should be compact. 25.39. In the year 2005, what is the difference between the Exports(as % of merchandise exports) in Australia and Exports(as % of merchandise exports) in Spain?
Your answer should be very brief. 22.61. In the year 2005, what is the difference between the Exports(as % of merchandise exports) in Ghana and Exports(as % of merchandise exports) in Iceland?
Your response must be concise. 1.98. In the year 2005, what is the difference between the Exports(as % of merchandise exports) of Ghana and Exports(as % of merchandise exports) of Spain?
Make the answer very short. -0.8. In the year 2005, what is the difference between the Exports(as % of merchandise exports) in Iceland and Exports(as % of merchandise exports) in Spain?
Give a very brief answer. -2.78. In the year 2006, what is the difference between the Exports(as % of merchandise exports) in Australia and Exports(as % of merchandise exports) in Ghana?
Make the answer very short. 24.82. In the year 2006, what is the difference between the Exports(as % of merchandise exports) in Australia and Exports(as % of merchandise exports) in Iceland?
Your answer should be compact. 23.15. In the year 2006, what is the difference between the Exports(as % of merchandise exports) in Australia and Exports(as % of merchandise exports) in Spain?
Ensure brevity in your answer.  21.03. In the year 2006, what is the difference between the Exports(as % of merchandise exports) of Ghana and Exports(as % of merchandise exports) of Iceland?
Provide a short and direct response. -1.68. In the year 2006, what is the difference between the Exports(as % of merchandise exports) of Ghana and Exports(as % of merchandise exports) of Spain?
Offer a very short reply. -3.79. In the year 2006, what is the difference between the Exports(as % of merchandise exports) of Iceland and Exports(as % of merchandise exports) of Spain?
Keep it short and to the point. -2.12. In the year 2007, what is the difference between the Exports(as % of merchandise exports) in Australia and Exports(as % of merchandise exports) in Ghana?
Ensure brevity in your answer.  23.12. In the year 2007, what is the difference between the Exports(as % of merchandise exports) in Australia and Exports(as % of merchandise exports) in Iceland?
Your answer should be compact. 22.96. In the year 2007, what is the difference between the Exports(as % of merchandise exports) of Australia and Exports(as % of merchandise exports) of Spain?
Your response must be concise. 19.92. In the year 2007, what is the difference between the Exports(as % of merchandise exports) of Ghana and Exports(as % of merchandise exports) of Iceland?
Make the answer very short. -0.16. In the year 2007, what is the difference between the Exports(as % of merchandise exports) of Ghana and Exports(as % of merchandise exports) of Spain?
Provide a succinct answer. -3.21. In the year 2007, what is the difference between the Exports(as % of merchandise exports) of Iceland and Exports(as % of merchandise exports) of Spain?
Provide a short and direct response. -3.05. In the year 2008, what is the difference between the Exports(as % of merchandise exports) in Australia and Exports(as % of merchandise exports) in Ghana?
Your answer should be very brief. 31.85. In the year 2008, what is the difference between the Exports(as % of merchandise exports) of Australia and Exports(as % of merchandise exports) of Iceland?
Provide a short and direct response. 32.78. In the year 2008, what is the difference between the Exports(as % of merchandise exports) of Australia and Exports(as % of merchandise exports) of Spain?
Ensure brevity in your answer.  27.89. In the year 2008, what is the difference between the Exports(as % of merchandise exports) in Ghana and Exports(as % of merchandise exports) in Iceland?
Offer a very short reply. 0.93. In the year 2008, what is the difference between the Exports(as % of merchandise exports) of Ghana and Exports(as % of merchandise exports) of Spain?
Provide a short and direct response. -3.96. In the year 2008, what is the difference between the Exports(as % of merchandise exports) in Iceland and Exports(as % of merchandise exports) in Spain?
Your answer should be very brief. -4.89. In the year 2009, what is the difference between the Exports(as % of merchandise exports) of Australia and Exports(as % of merchandise exports) of Ghana?
Your answer should be compact. 27.8. In the year 2009, what is the difference between the Exports(as % of merchandise exports) in Australia and Exports(as % of merchandise exports) in Iceland?
Provide a succinct answer. 30.99. In the year 2009, what is the difference between the Exports(as % of merchandise exports) of Australia and Exports(as % of merchandise exports) of Spain?
Give a very brief answer. 27.58. In the year 2009, what is the difference between the Exports(as % of merchandise exports) in Ghana and Exports(as % of merchandise exports) in Iceland?
Keep it short and to the point. 3.19. In the year 2009, what is the difference between the Exports(as % of merchandise exports) of Ghana and Exports(as % of merchandise exports) of Spain?
Your answer should be very brief. -0.22. In the year 2009, what is the difference between the Exports(as % of merchandise exports) in Iceland and Exports(as % of merchandise exports) in Spain?
Your response must be concise. -3.41. In the year 2010, what is the difference between the Exports(as % of merchandise exports) in Australia and Exports(as % of merchandise exports) in Ghana?
Offer a very short reply. 30.53. In the year 2010, what is the difference between the Exports(as % of merchandise exports) in Australia and Exports(as % of merchandise exports) in Iceland?
Offer a very short reply. 29.83. In the year 2010, what is the difference between the Exports(as % of merchandise exports) in Australia and Exports(as % of merchandise exports) in Spain?
Ensure brevity in your answer.  25.92. In the year 2010, what is the difference between the Exports(as % of merchandise exports) in Ghana and Exports(as % of merchandise exports) in Iceland?
Your answer should be compact. -0.71. In the year 2010, what is the difference between the Exports(as % of merchandise exports) of Ghana and Exports(as % of merchandise exports) of Spain?
Ensure brevity in your answer.  -4.61. In the year 2010, what is the difference between the Exports(as % of merchandise exports) of Iceland and Exports(as % of merchandise exports) of Spain?
Offer a very short reply. -3.91. In the year 2011, what is the difference between the Exports(as % of merchandise exports) of Australia and Exports(as % of merchandise exports) of Ghana?
Offer a very short reply. -25.23. In the year 2011, what is the difference between the Exports(as % of merchandise exports) in Australia and Exports(as % of merchandise exports) in Iceland?
Your answer should be compact. 27.95. In the year 2011, what is the difference between the Exports(as % of merchandise exports) in Australia and Exports(as % of merchandise exports) in Spain?
Your response must be concise. 22.61. In the year 2011, what is the difference between the Exports(as % of merchandise exports) in Ghana and Exports(as % of merchandise exports) in Iceland?
Offer a terse response. 53.18. In the year 2011, what is the difference between the Exports(as % of merchandise exports) in Ghana and Exports(as % of merchandise exports) in Spain?
Offer a very short reply. 47.84. In the year 2011, what is the difference between the Exports(as % of merchandise exports) in Iceland and Exports(as % of merchandise exports) in Spain?
Keep it short and to the point. -5.34. What is the ratio of the Exports(as % of merchandise exports) in Australia in 2005 to that in 2006?
Your answer should be very brief. 1.05. What is the ratio of the Exports(as % of merchandise exports) of Ghana in 2005 to that in 2006?
Offer a terse response. 5.16. What is the ratio of the Exports(as % of merchandise exports) of Iceland in 2005 to that in 2006?
Keep it short and to the point. 0.6. What is the ratio of the Exports(as % of merchandise exports) of Spain in 2005 to that in 2006?
Ensure brevity in your answer.  0.94. What is the ratio of the Exports(as % of merchandise exports) of Australia in 2005 to that in 2007?
Provide a short and direct response. 1.1. What is the ratio of the Exports(as % of merchandise exports) of Ghana in 2005 to that in 2007?
Ensure brevity in your answer.  2.61. What is the ratio of the Exports(as % of merchandise exports) of Iceland in 2005 to that in 2007?
Ensure brevity in your answer.  0.96. What is the ratio of the Exports(as % of merchandise exports) of Spain in 2005 to that in 2007?
Offer a terse response. 0.93. What is the ratio of the Exports(as % of merchandise exports) of Australia in 2005 to that in 2008?
Provide a succinct answer. 0.78. What is the ratio of the Exports(as % of merchandise exports) in Ghana in 2005 to that in 2008?
Provide a short and direct response. 1.4. What is the ratio of the Exports(as % of merchandise exports) of Iceland in 2005 to that in 2008?
Provide a succinct answer. 0.94. What is the ratio of the Exports(as % of merchandise exports) of Spain in 2005 to that in 2008?
Provide a succinct answer. 0.65. What is the ratio of the Exports(as % of merchandise exports) in Australia in 2005 to that in 2009?
Provide a succinct answer. 0.84. What is the ratio of the Exports(as % of merchandise exports) of Ghana in 2005 to that in 2009?
Keep it short and to the point. 0.81. What is the ratio of the Exports(as % of merchandise exports) in Iceland in 2005 to that in 2009?
Offer a very short reply. 1.41. What is the ratio of the Exports(as % of merchandise exports) of Spain in 2005 to that in 2009?
Ensure brevity in your answer.  0.95. What is the ratio of the Exports(as % of merchandise exports) of Australia in 2005 to that in 2010?
Offer a terse response. 0.87. What is the ratio of the Exports(as % of merchandise exports) in Ghana in 2005 to that in 2010?
Make the answer very short. 10.44. What is the ratio of the Exports(as % of merchandise exports) in Iceland in 2005 to that in 2010?
Your answer should be very brief. 1.36. What is the ratio of the Exports(as % of merchandise exports) in Spain in 2005 to that in 2010?
Provide a short and direct response. 0.85. What is the ratio of the Exports(as % of merchandise exports) of Australia in 2005 to that in 2011?
Offer a terse response. 0.9. What is the ratio of the Exports(as % of merchandise exports) in Ghana in 2005 to that in 2011?
Offer a very short reply. 0.06. What is the ratio of the Exports(as % of merchandise exports) of Iceland in 2005 to that in 2011?
Your answer should be very brief. 0.72. What is the ratio of the Exports(as % of merchandise exports) of Spain in 2005 to that in 2011?
Offer a very short reply. 0.57. What is the ratio of the Exports(as % of merchandise exports) of Australia in 2006 to that in 2007?
Provide a short and direct response. 1.04. What is the ratio of the Exports(as % of merchandise exports) of Ghana in 2006 to that in 2007?
Your response must be concise. 0.51. What is the ratio of the Exports(as % of merchandise exports) of Iceland in 2006 to that in 2007?
Make the answer very short. 1.6. What is the ratio of the Exports(as % of merchandise exports) of Spain in 2006 to that in 2007?
Ensure brevity in your answer.  0.99. What is the ratio of the Exports(as % of merchandise exports) in Australia in 2006 to that in 2008?
Your answer should be compact. 0.74. What is the ratio of the Exports(as % of merchandise exports) in Ghana in 2006 to that in 2008?
Offer a terse response. 0.27. What is the ratio of the Exports(as % of merchandise exports) of Iceland in 2006 to that in 2008?
Give a very brief answer. 1.57. What is the ratio of the Exports(as % of merchandise exports) of Spain in 2006 to that in 2008?
Ensure brevity in your answer.  0.7. What is the ratio of the Exports(as % of merchandise exports) in Australia in 2006 to that in 2009?
Offer a terse response. 0.8. What is the ratio of the Exports(as % of merchandise exports) of Ghana in 2006 to that in 2009?
Provide a succinct answer. 0.16. What is the ratio of the Exports(as % of merchandise exports) in Iceland in 2006 to that in 2009?
Offer a terse response. 2.35. What is the ratio of the Exports(as % of merchandise exports) of Spain in 2006 to that in 2009?
Provide a succinct answer. 1.01. What is the ratio of the Exports(as % of merchandise exports) of Australia in 2006 to that in 2010?
Your response must be concise. 0.83. What is the ratio of the Exports(as % of merchandise exports) in Ghana in 2006 to that in 2010?
Keep it short and to the point. 2.02. What is the ratio of the Exports(as % of merchandise exports) in Iceland in 2006 to that in 2010?
Provide a succinct answer. 2.27. What is the ratio of the Exports(as % of merchandise exports) in Spain in 2006 to that in 2010?
Make the answer very short. 0.9. What is the ratio of the Exports(as % of merchandise exports) in Australia in 2006 to that in 2011?
Offer a very short reply. 0.85. What is the ratio of the Exports(as % of merchandise exports) of Ghana in 2006 to that in 2011?
Ensure brevity in your answer.  0.01. What is the ratio of the Exports(as % of merchandise exports) in Iceland in 2006 to that in 2011?
Keep it short and to the point. 1.21. What is the ratio of the Exports(as % of merchandise exports) in Spain in 2006 to that in 2011?
Provide a short and direct response. 0.61. What is the ratio of the Exports(as % of merchandise exports) of Australia in 2007 to that in 2008?
Ensure brevity in your answer.  0.71. What is the ratio of the Exports(as % of merchandise exports) in Ghana in 2007 to that in 2008?
Keep it short and to the point. 0.54. What is the ratio of the Exports(as % of merchandise exports) in Iceland in 2007 to that in 2008?
Provide a succinct answer. 0.98. What is the ratio of the Exports(as % of merchandise exports) in Spain in 2007 to that in 2008?
Your answer should be compact. 0.71. What is the ratio of the Exports(as % of merchandise exports) of Australia in 2007 to that in 2009?
Your answer should be very brief. 0.76. What is the ratio of the Exports(as % of merchandise exports) of Ghana in 2007 to that in 2009?
Offer a terse response. 0.31. What is the ratio of the Exports(as % of merchandise exports) in Iceland in 2007 to that in 2009?
Your answer should be very brief. 1.47. What is the ratio of the Exports(as % of merchandise exports) in Spain in 2007 to that in 2009?
Offer a terse response. 1.02. What is the ratio of the Exports(as % of merchandise exports) in Australia in 2007 to that in 2010?
Keep it short and to the point. 0.79. What is the ratio of the Exports(as % of merchandise exports) in Ghana in 2007 to that in 2010?
Your answer should be compact. 3.99. What is the ratio of the Exports(as % of merchandise exports) in Iceland in 2007 to that in 2010?
Keep it short and to the point. 1.41. What is the ratio of the Exports(as % of merchandise exports) of Spain in 2007 to that in 2010?
Offer a very short reply. 0.91. What is the ratio of the Exports(as % of merchandise exports) of Australia in 2007 to that in 2011?
Provide a succinct answer. 0.82. What is the ratio of the Exports(as % of merchandise exports) of Ghana in 2007 to that in 2011?
Offer a very short reply. 0.02. What is the ratio of the Exports(as % of merchandise exports) of Iceland in 2007 to that in 2011?
Keep it short and to the point. 0.75. What is the ratio of the Exports(as % of merchandise exports) of Spain in 2007 to that in 2011?
Provide a succinct answer. 0.62. What is the ratio of the Exports(as % of merchandise exports) in Australia in 2008 to that in 2009?
Your answer should be very brief. 1.07. What is the ratio of the Exports(as % of merchandise exports) in Ghana in 2008 to that in 2009?
Give a very brief answer. 0.58. What is the ratio of the Exports(as % of merchandise exports) in Iceland in 2008 to that in 2009?
Keep it short and to the point. 1.5. What is the ratio of the Exports(as % of merchandise exports) of Spain in 2008 to that in 2009?
Your response must be concise. 1.45. What is the ratio of the Exports(as % of merchandise exports) of Australia in 2008 to that in 2010?
Offer a very short reply. 1.11. What is the ratio of the Exports(as % of merchandise exports) of Ghana in 2008 to that in 2010?
Keep it short and to the point. 7.47. What is the ratio of the Exports(as % of merchandise exports) in Iceland in 2008 to that in 2010?
Provide a short and direct response. 1.44. What is the ratio of the Exports(as % of merchandise exports) in Spain in 2008 to that in 2010?
Make the answer very short. 1.29. What is the ratio of the Exports(as % of merchandise exports) in Australia in 2008 to that in 2011?
Give a very brief answer. 1.15. What is the ratio of the Exports(as % of merchandise exports) of Ghana in 2008 to that in 2011?
Your response must be concise. 0.04. What is the ratio of the Exports(as % of merchandise exports) of Iceland in 2008 to that in 2011?
Make the answer very short. 0.77. What is the ratio of the Exports(as % of merchandise exports) in Spain in 2008 to that in 2011?
Keep it short and to the point. 0.88. What is the ratio of the Exports(as % of merchandise exports) of Australia in 2009 to that in 2010?
Offer a terse response. 1.04. What is the ratio of the Exports(as % of merchandise exports) of Ghana in 2009 to that in 2010?
Provide a short and direct response. 12.93. What is the ratio of the Exports(as % of merchandise exports) of Iceland in 2009 to that in 2010?
Your answer should be very brief. 0.96. What is the ratio of the Exports(as % of merchandise exports) of Spain in 2009 to that in 2010?
Make the answer very short. 0.89. What is the ratio of the Exports(as % of merchandise exports) in Australia in 2009 to that in 2011?
Your response must be concise. 1.07. What is the ratio of the Exports(as % of merchandise exports) of Ghana in 2009 to that in 2011?
Keep it short and to the point. 0.08. What is the ratio of the Exports(as % of merchandise exports) of Iceland in 2009 to that in 2011?
Your response must be concise. 0.51. What is the ratio of the Exports(as % of merchandise exports) in Spain in 2009 to that in 2011?
Keep it short and to the point. 0.61. What is the ratio of the Exports(as % of merchandise exports) in Australia in 2010 to that in 2011?
Ensure brevity in your answer.  1.03. What is the ratio of the Exports(as % of merchandise exports) in Ghana in 2010 to that in 2011?
Offer a very short reply. 0.01. What is the ratio of the Exports(as % of merchandise exports) of Iceland in 2010 to that in 2011?
Your answer should be very brief. 0.53. What is the ratio of the Exports(as % of merchandise exports) in Spain in 2010 to that in 2011?
Keep it short and to the point. 0.68. What is the difference between the highest and the second highest Exports(as % of merchandise exports) of Australia?
Ensure brevity in your answer.  2.29. What is the difference between the highest and the second highest Exports(as % of merchandise exports) of Ghana?
Ensure brevity in your answer.  50.93. What is the difference between the highest and the second highest Exports(as % of merchandise exports) of Iceland?
Offer a very short reply. 0.4. What is the difference between the highest and the second highest Exports(as % of merchandise exports) in Spain?
Ensure brevity in your answer.  0.9. What is the difference between the highest and the lowest Exports(as % of merchandise exports) of Australia?
Give a very brief answer. 9.85. What is the difference between the highest and the lowest Exports(as % of merchandise exports) in Ghana?
Offer a very short reply. 54.79. What is the difference between the highest and the lowest Exports(as % of merchandise exports) of Iceland?
Offer a terse response. 1.34. What is the difference between the highest and the lowest Exports(as % of merchandise exports) of Spain?
Ensure brevity in your answer.  3.1. 